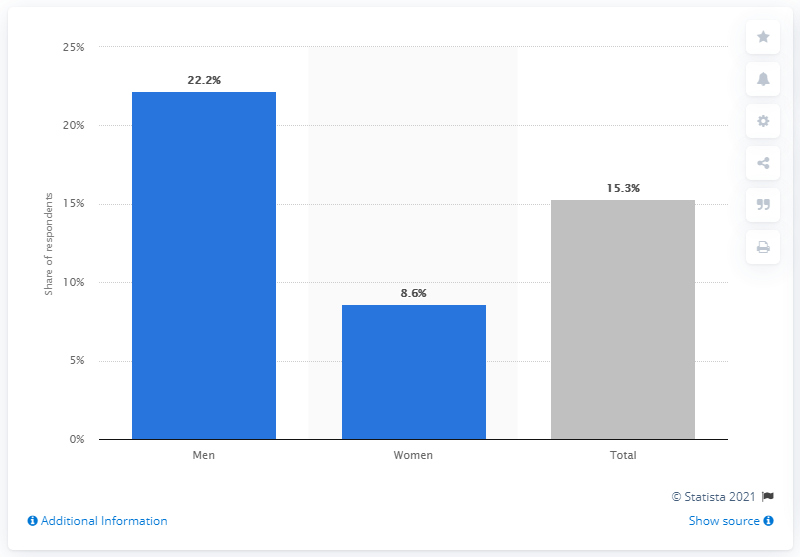How does the percentage of men searching for sexual partners compare to that of women? The percentage of men represented in blue is significantly higher at 22.2%, compared to the 8.6% for women, indicating that men are more likely to search for sexual partners on the internet according to this data. 